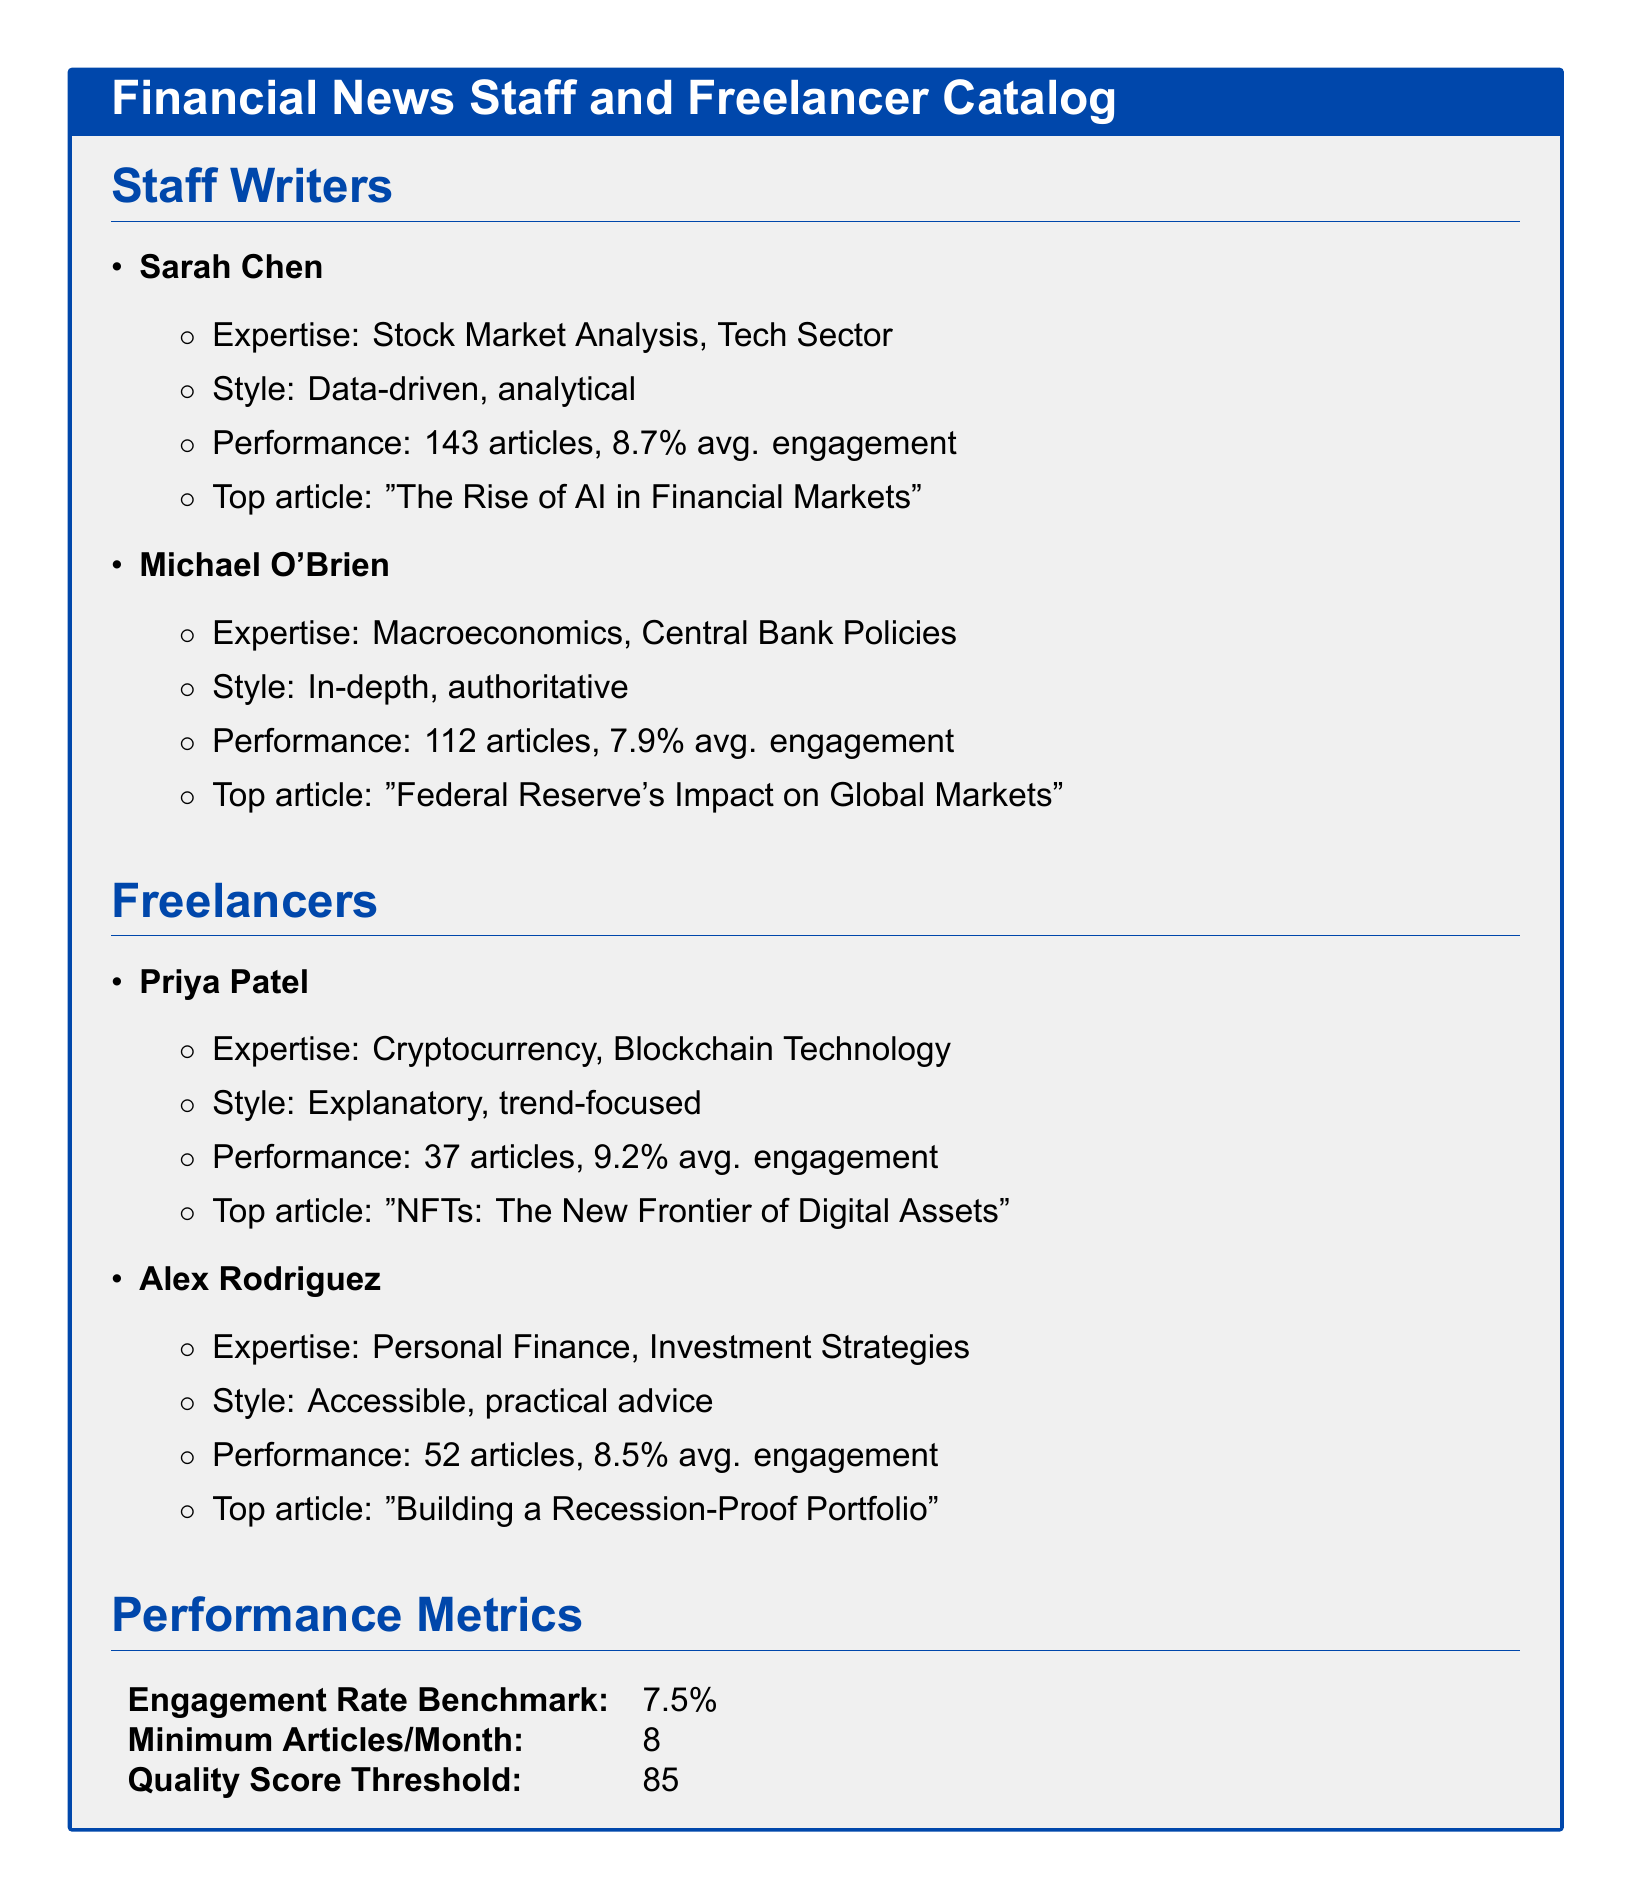What is Sarah Chen's area of expertise? Sarah Chen's expertise can be found listed under her section in the catalog, specifically mentioning Stock Market Analysis and the Tech Sector.
Answer: Stock Market Analysis, Tech Sector How many articles has Michael O'Brien written? The number of articles Michael O'Brien has written is stated in the document as part of his performance metrics.
Answer: 112 articles What is Priya Patel's average engagement rate? Priya Patel's average engagement rate can be found in her performance metrics, which indicate a specific percentage.
Answer: 9.2% Which writer has expertise in cryptocurrency? The document specifies Priya Patel's area of expertise, identifying her focus on cryptocurrency and blockchain technology.
Answer: Priya Patel What is the engagement rate benchmark listed in the document? The engagement rate benchmark is directly listed in the performance metrics section of the catalog.
Answer: 7.5% Which staff writer has the highest average engagement? To determine this, one can compare the average engagement rates of the staff writers mentioned in the document.
Answer: Sarah Chen What is the minimum number of articles a writer is expected to publish per month? The document states a specific numeric threshold for the minimum articles expected from each writer in the performance metrics section.
Answer: 8 What style does Alex Rodriguez employ in his writings? Alex Rodriguez's writing style is indicated in his description, highlighting the nature of his advice.
Answer: Accessible, practical advice 